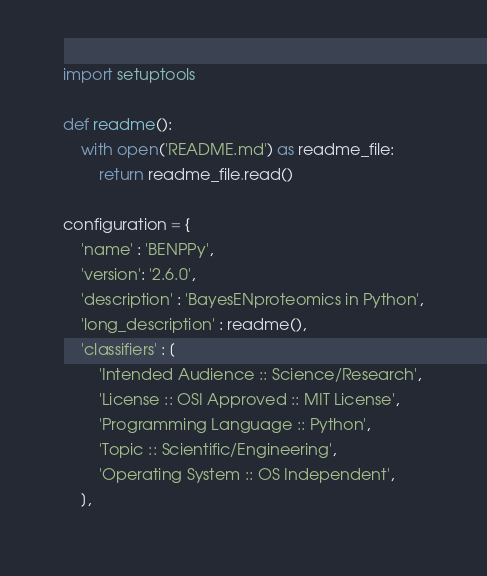<code> <loc_0><loc_0><loc_500><loc_500><_Python_>import setuptools

def readme():
    with open('README.md') as readme_file:
        return readme_file.read()

configuration = {
    'name' : 'BENPPy',
    'version': '2.6.0',
    'description' : 'BayesENproteomics in Python',
    'long_description' : readme(),
    'classifiers' : [
        'Intended Audience :: Science/Research',
        'License :: OSI Approved :: MIT License',
        'Programming Language :: Python',
        'Topic :: Scientific/Engineering',
        'Operating System :: OS Independent',
    ],</code> 